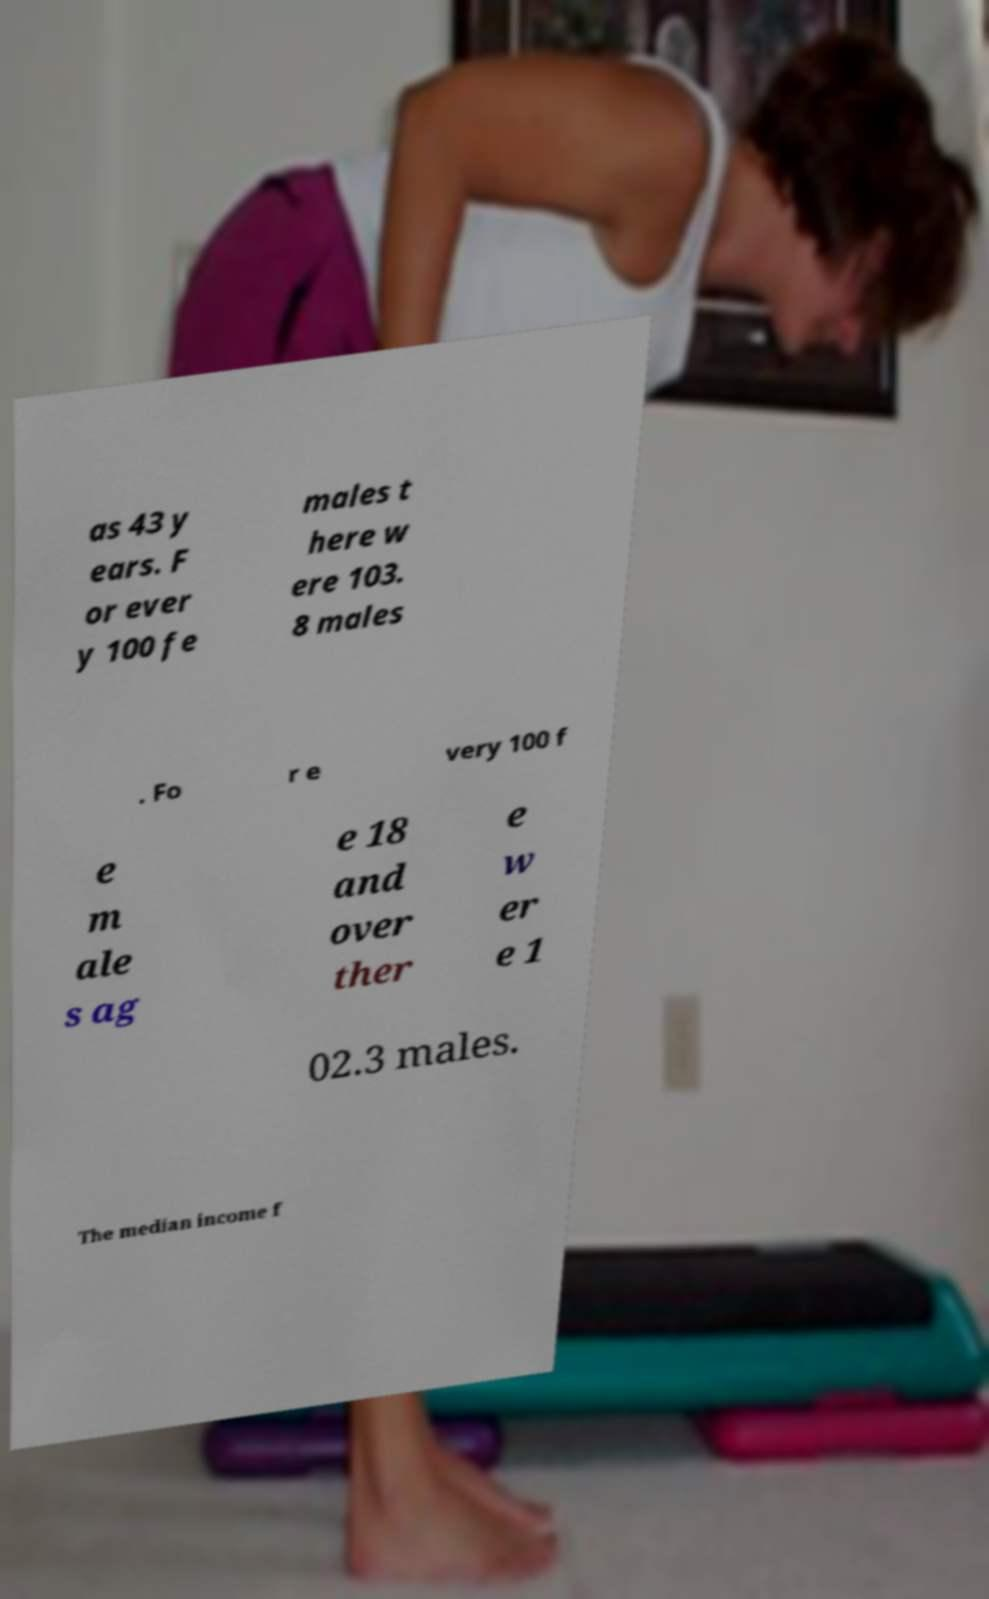For documentation purposes, I need the text within this image transcribed. Could you provide that? as 43 y ears. F or ever y 100 fe males t here w ere 103. 8 males . Fo r e very 100 f e m ale s ag e 18 and over ther e w er e 1 02.3 males. The median income f 